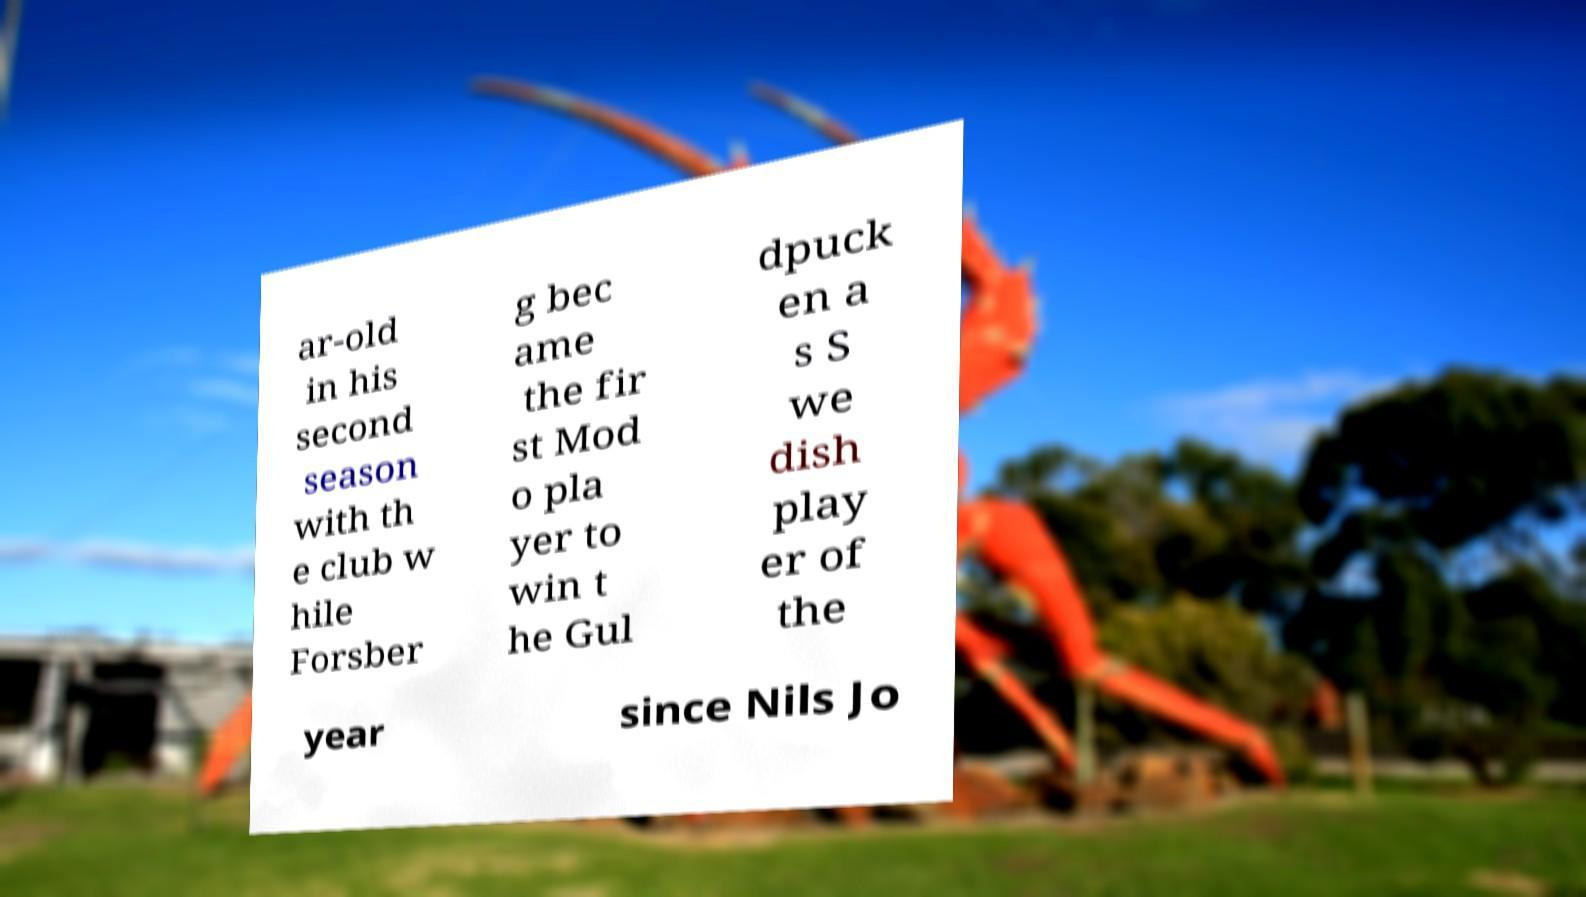Please identify and transcribe the text found in this image. ar-old in his second season with th e club w hile Forsber g bec ame the fir st Mod o pla yer to win t he Gul dpuck en a s S we dish play er of the year since Nils Jo 